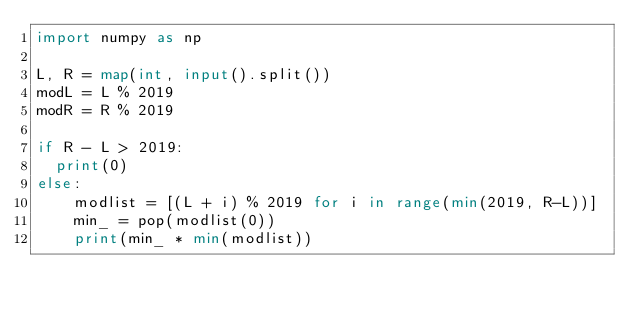<code> <loc_0><loc_0><loc_500><loc_500><_Python_>import numpy as np
 
L, R = map(int, input().split())
modL = L % 2019
modR = R % 2019
 
if R - L > 2019:
  print(0)
else:
	modlist = [(L + i) % 2019 for i in range(min(2019, R-L))]
    min_ = pop(modlist(0))
	print(min_ * min(modlist))</code> 